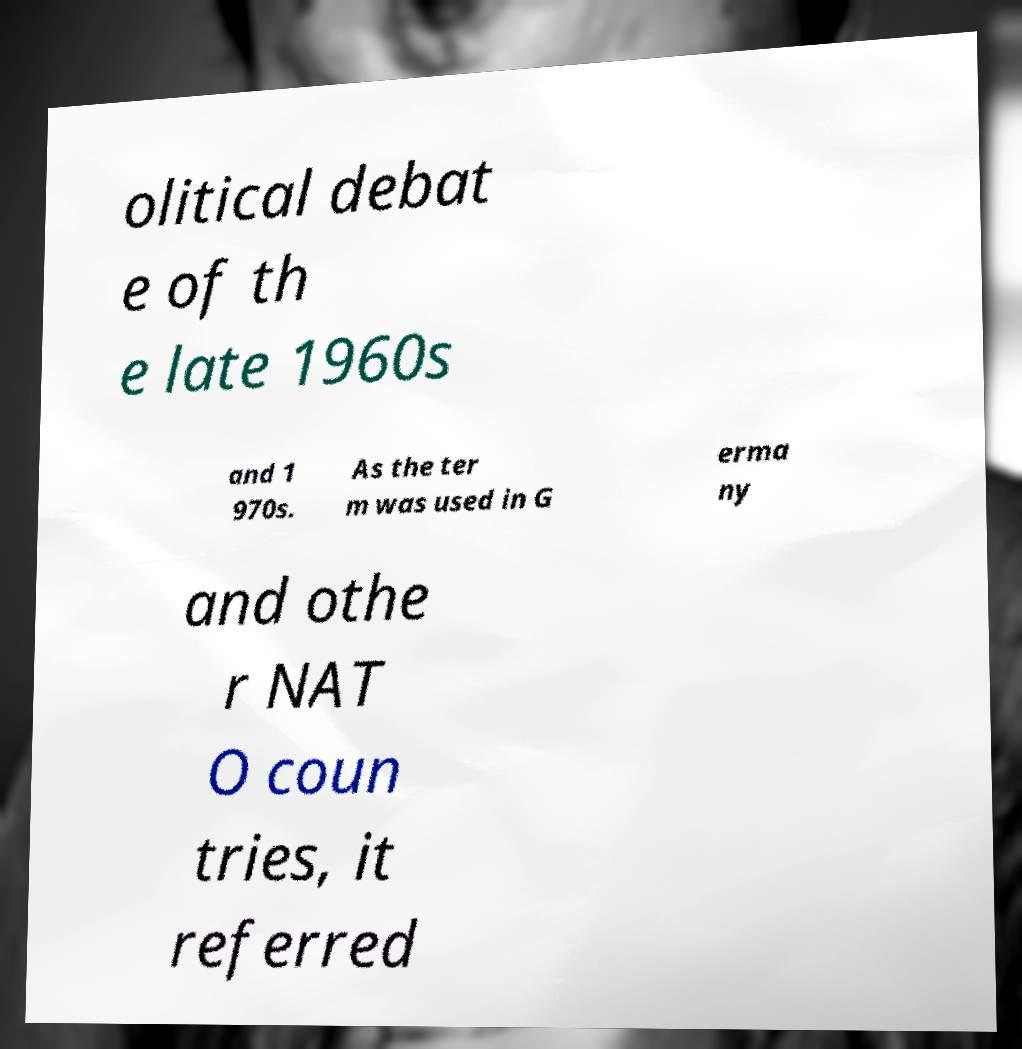There's text embedded in this image that I need extracted. Can you transcribe it verbatim? olitical debat e of th e late 1960s and 1 970s. As the ter m was used in G erma ny and othe r NAT O coun tries, it referred 